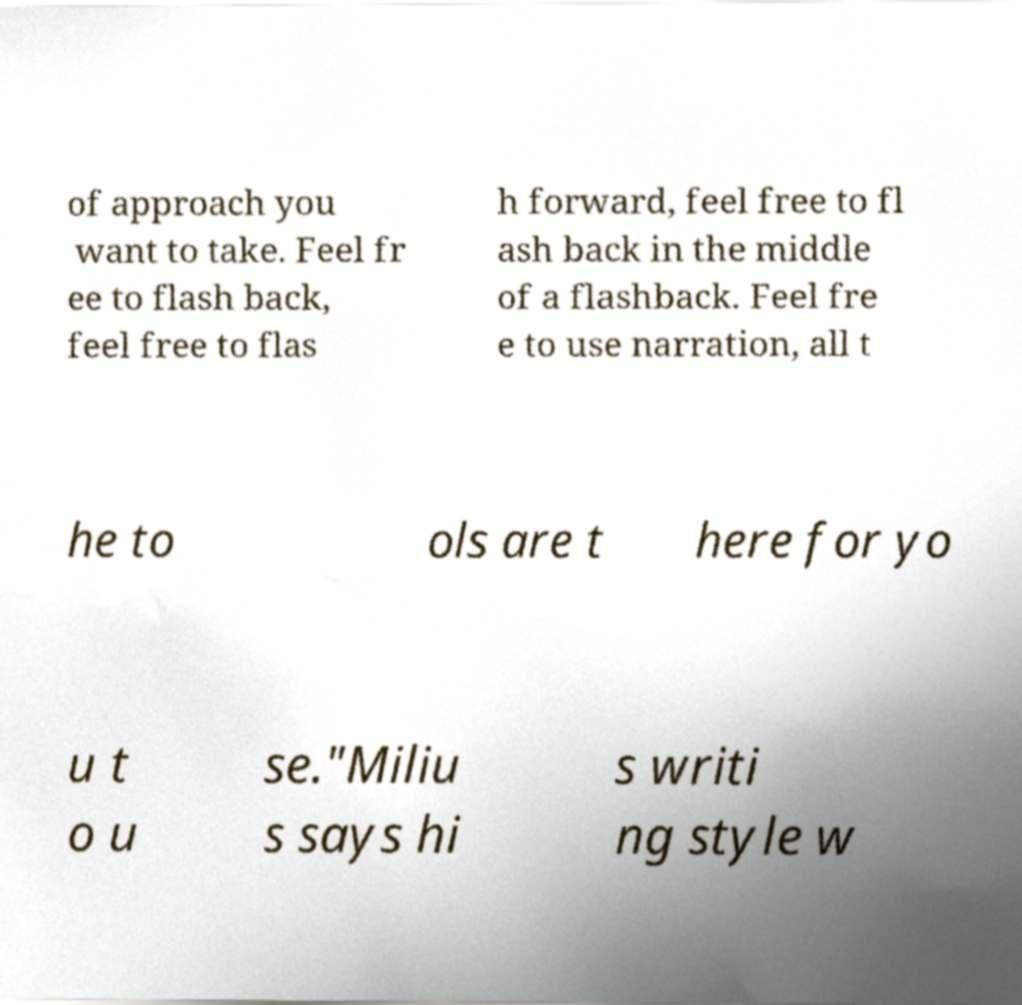Could you extract and type out the text from this image? of approach you want to take. Feel fr ee to flash back, feel free to flas h forward, feel free to fl ash back in the middle of a flashback. Feel fre e to use narration, all t he to ols are t here for yo u t o u se."Miliu s says hi s writi ng style w 